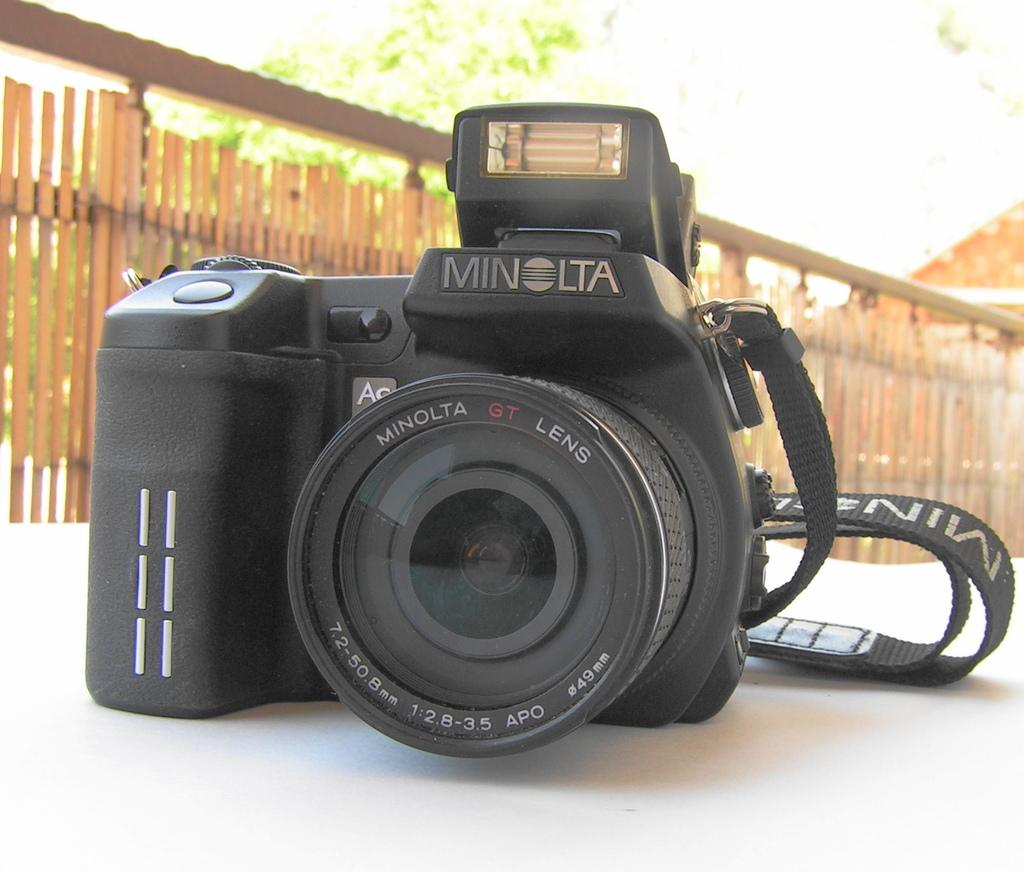What is the main object in the image? There is a camera in the image. What color is the surface on which the camera is placed? The camera is on a white color surface. What can be seen in the background of the image? There is a wooden boundary and a tree visible in the background of the image. How many screws are visible on the camera in the image? There are no screws visible on the camera in the image. What type of suit is the giraffe wearing in the image? There is no giraffe present in the image, so it cannot be wearing a suit. 